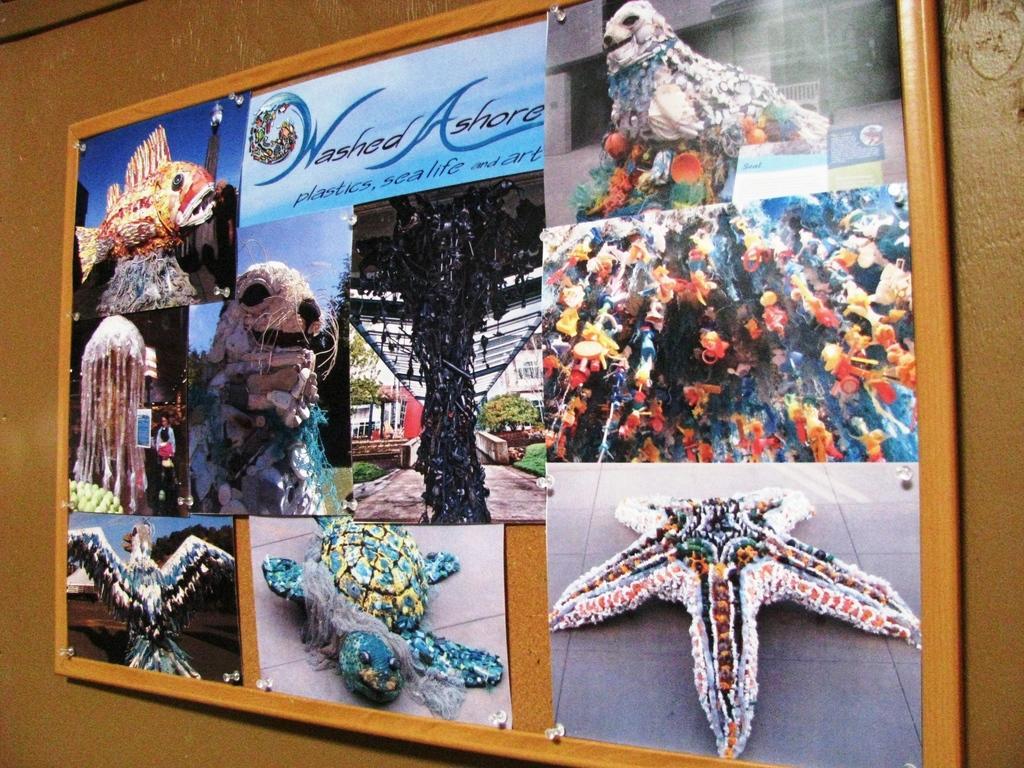Describe this image in one or two sentences. In this image we can see a board with pictures and text on it, which is on the wall. 